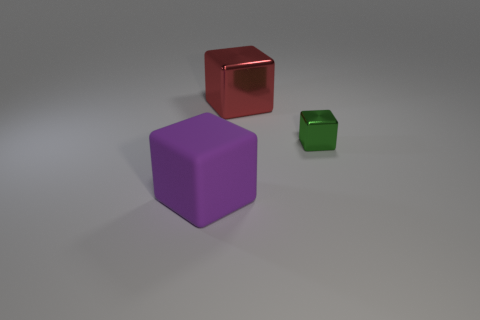How many tiny shiny cubes are the same color as the matte cube?
Offer a very short reply. 0. There is a big red metal block; are there any large metal objects in front of it?
Offer a very short reply. No. Are there an equal number of large matte blocks behind the large purple rubber block and purple cubes that are on the right side of the small green object?
Provide a succinct answer. Yes. There is a shiny cube that is on the left side of the small green shiny thing; is its size the same as the metallic cube that is in front of the big red thing?
Give a very brief answer. No. What shape is the red object that is behind the block on the right side of the metallic block that is behind the tiny green cube?
Make the answer very short. Cube. Are there any other things that are the same material as the purple block?
Your answer should be very brief. No. What size is the other metallic thing that is the same shape as the big red shiny thing?
Your answer should be very brief. Small. What color is the object that is both in front of the large metallic block and behind the large purple matte block?
Provide a short and direct response. Green. Are the big red block and the large thing that is in front of the small green block made of the same material?
Offer a very short reply. No. Is the number of big red things in front of the red block less than the number of tiny green metal blocks?
Keep it short and to the point. Yes. 